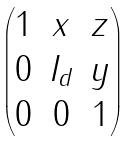Convert formula to latex. <formula><loc_0><loc_0><loc_500><loc_500>\begin{pmatrix} 1 & x & z \\ 0 & I _ { d } & y \\ 0 & 0 & 1 \end{pmatrix}</formula> 